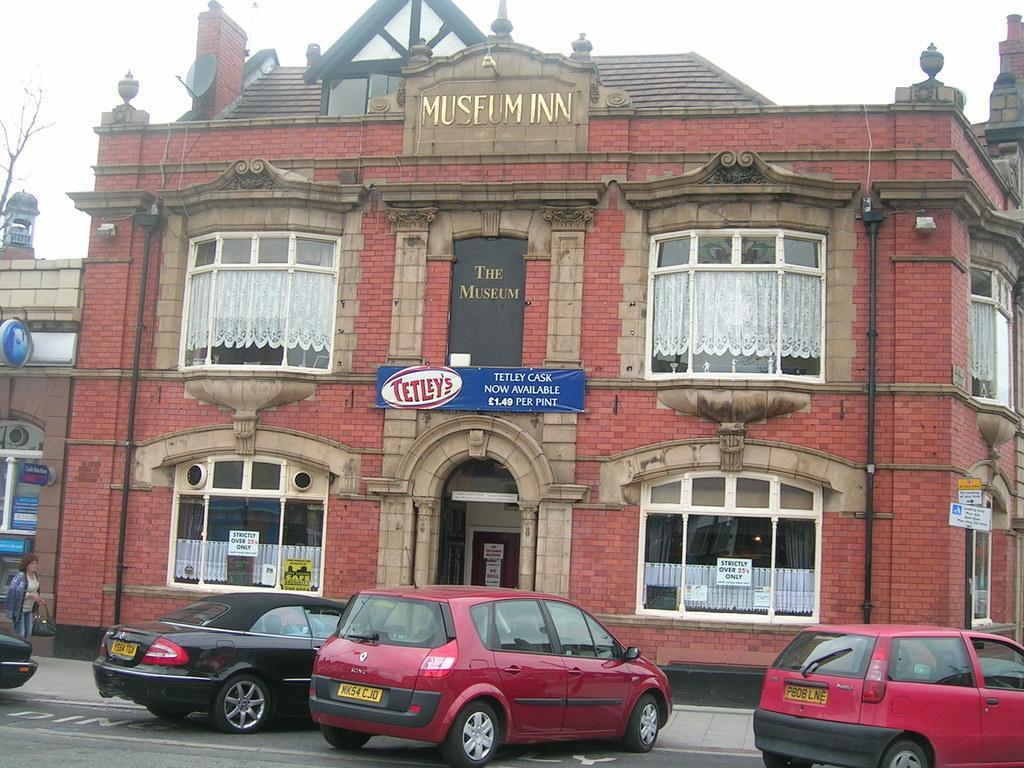How would you summarize this image in a sentence or two? In this image we can see a building. In front of the building cars are there on road. Left side of the image one dry tree is present. 